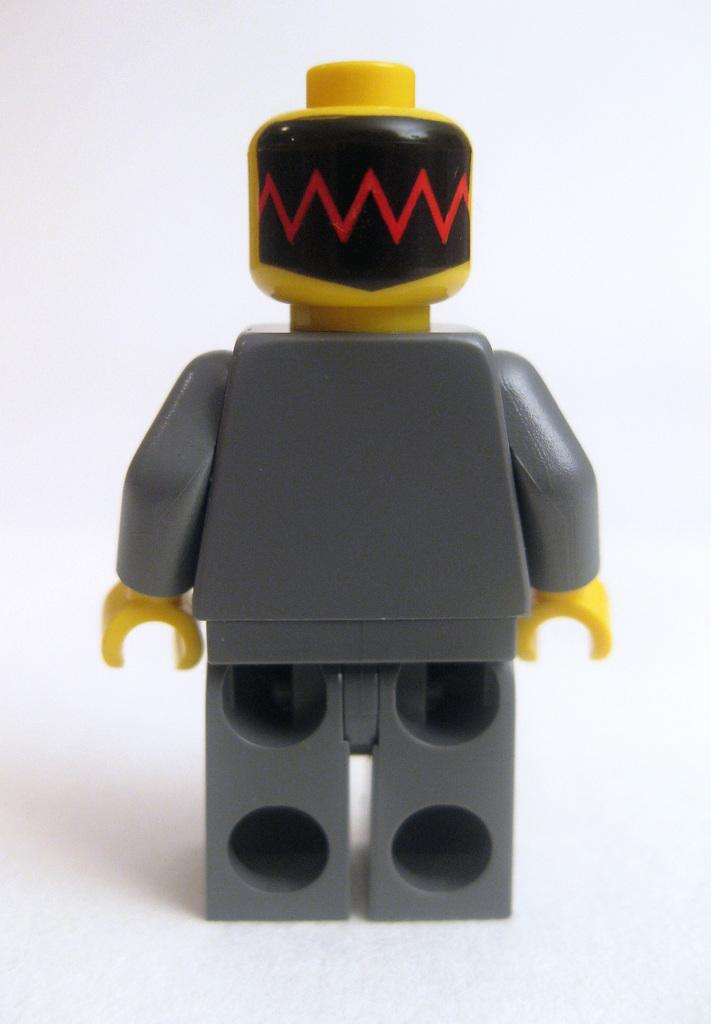What is the main subject of the image? There is a person (presumably the speaker) on a white platform. What is the color of the platform? The platform is white. What can be seen behind the person on the platform? The background of the image is white. What is the name of the twig that the person is holding in the image? There is no twig present in the image, and therefore no name can be given. 